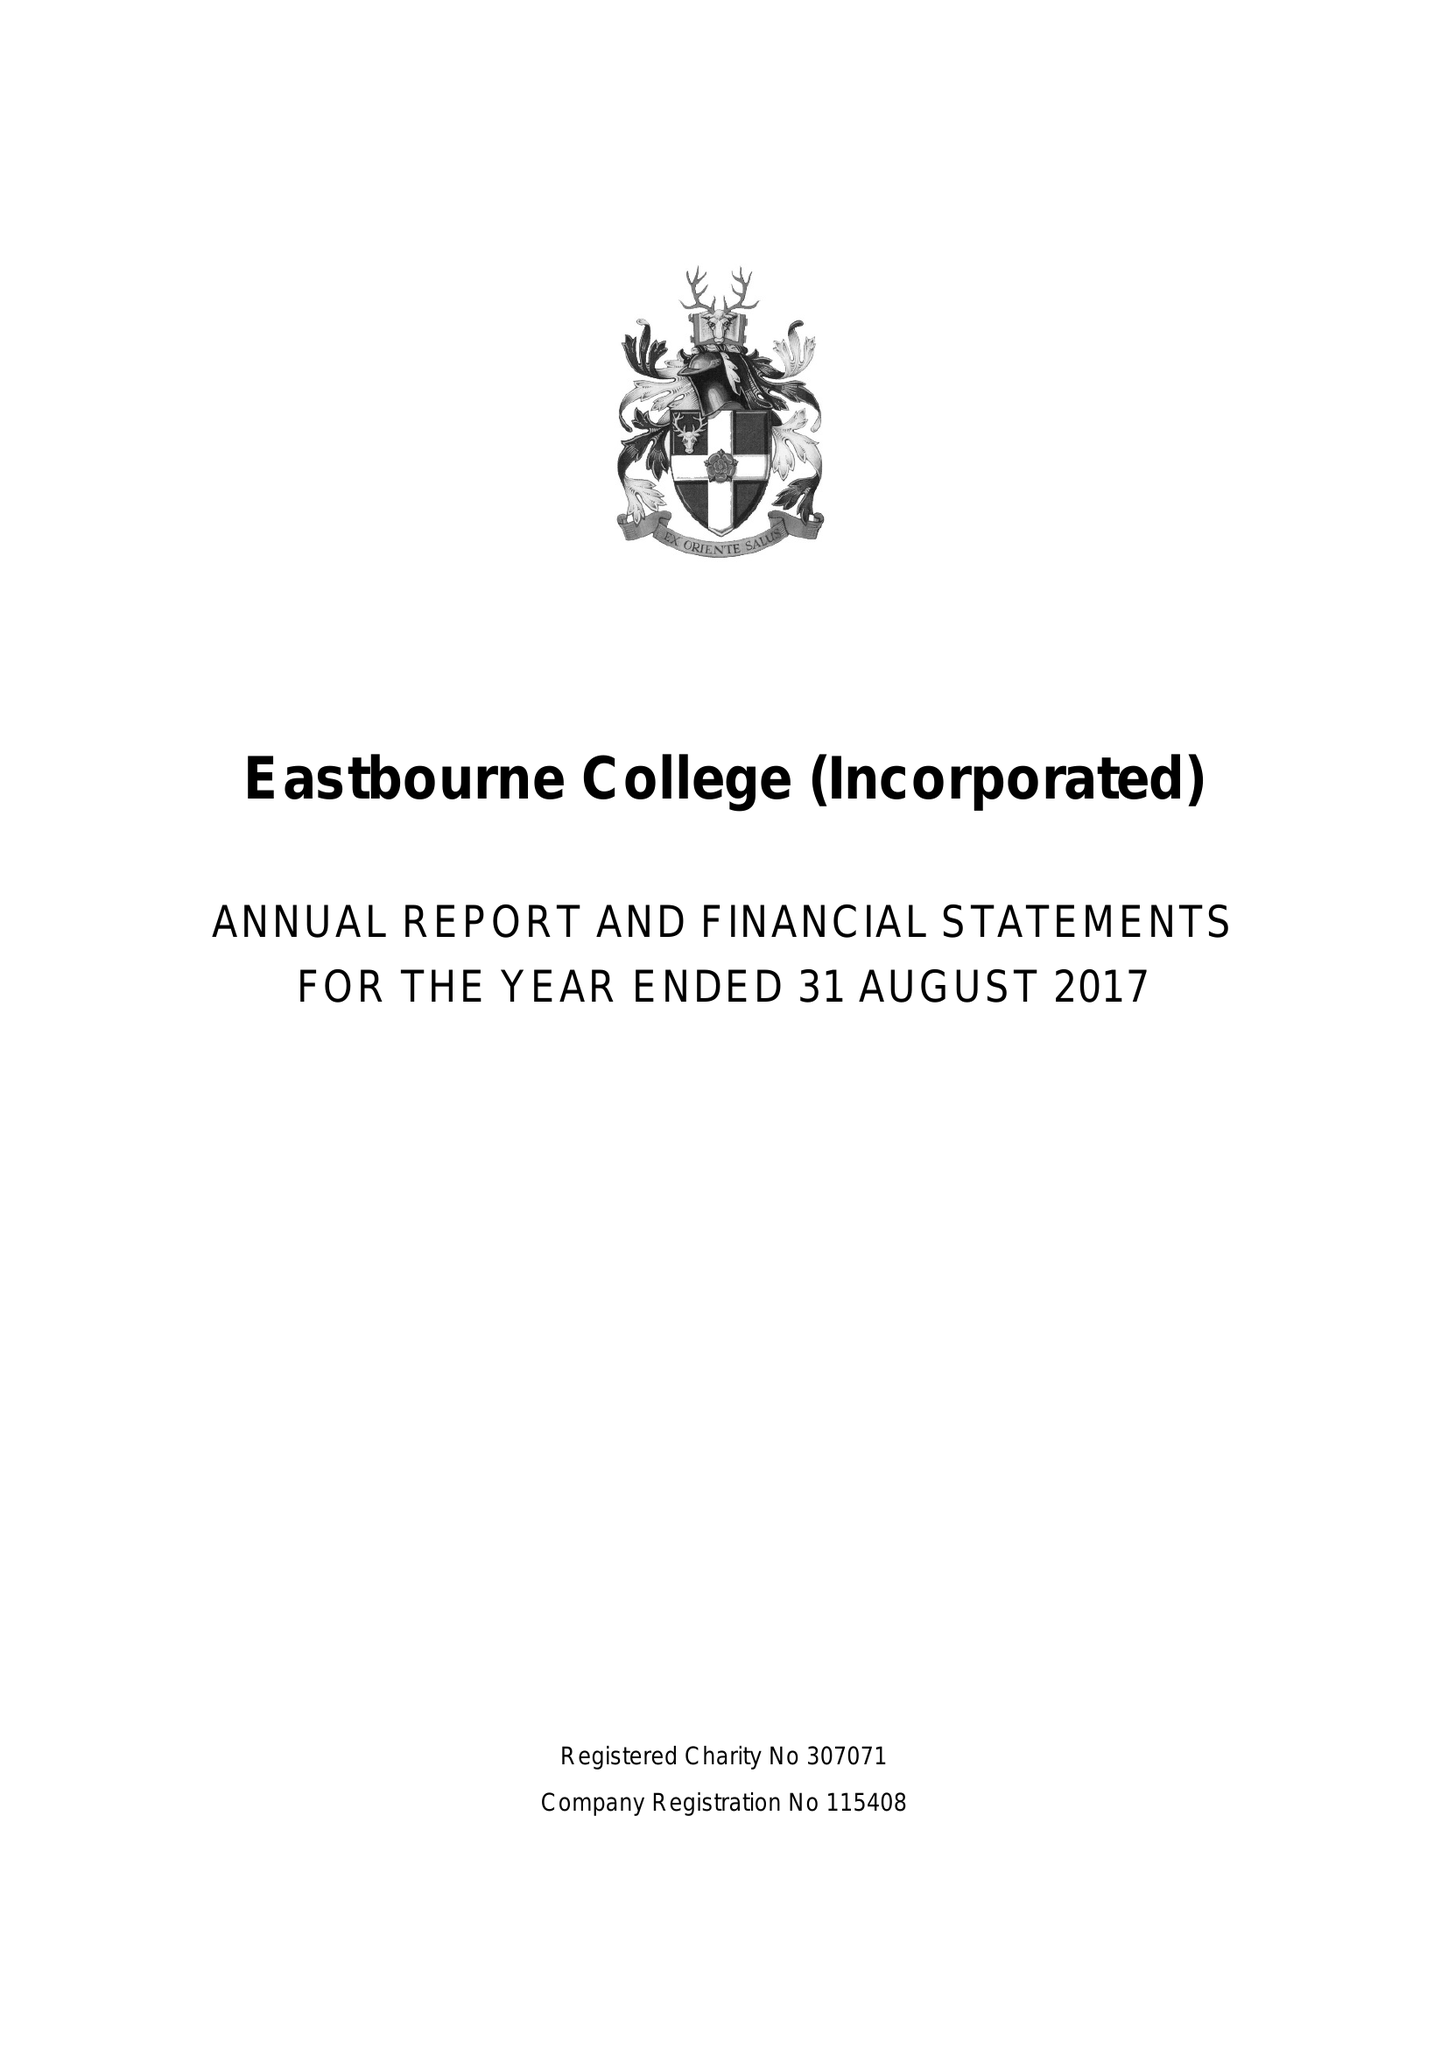What is the value for the address__post_town?
Answer the question using a single word or phrase. EASTBOURNE 